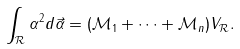<formula> <loc_0><loc_0><loc_500><loc_500>\int _ { \mathcal { R } } \alpha ^ { 2 } d \vec { \alpha } = ( { \mathcal { M } } _ { 1 } + \cdots + { \mathcal { M } } _ { n } ) V _ { \mathcal { R } } .</formula> 